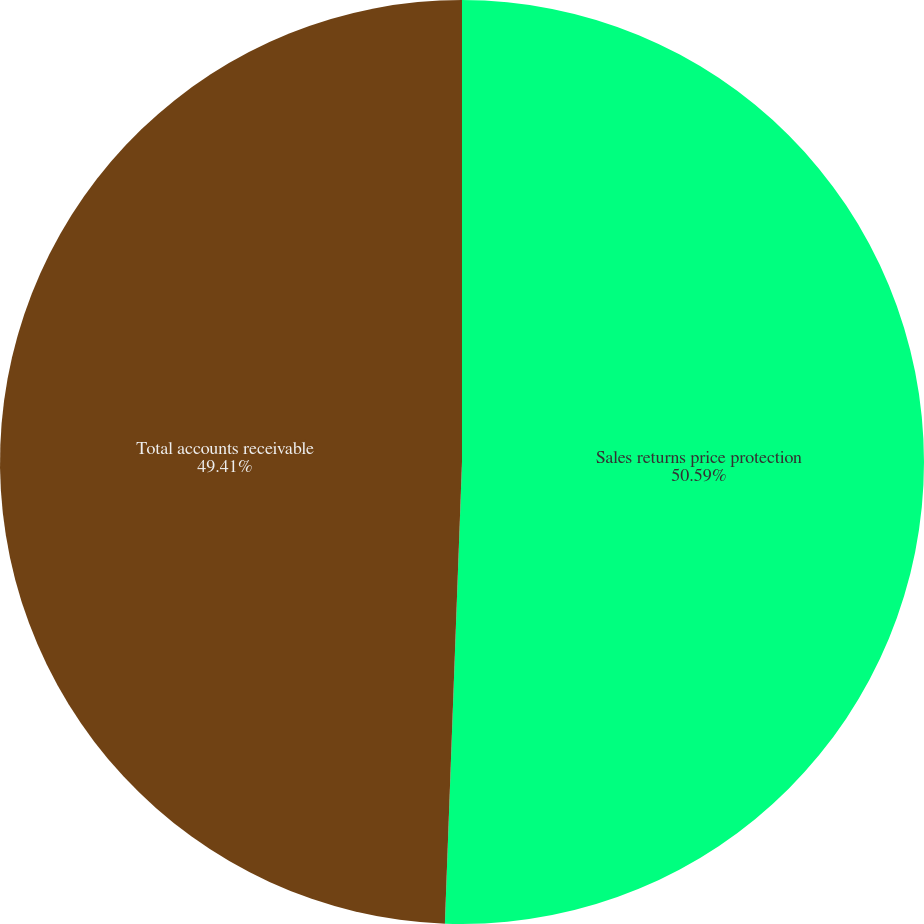<chart> <loc_0><loc_0><loc_500><loc_500><pie_chart><fcel>Sales returns price protection<fcel>Total accounts receivable<nl><fcel>50.59%<fcel>49.41%<nl></chart> 